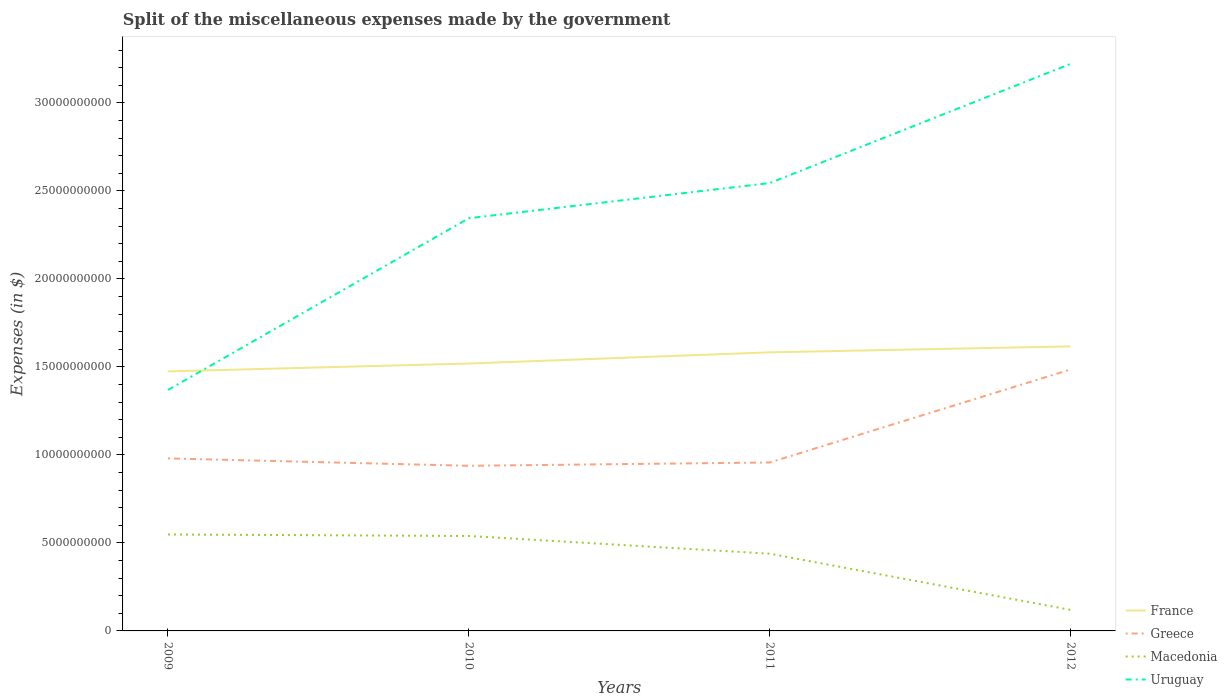How many different coloured lines are there?
Give a very brief answer. 4. Across all years, what is the maximum miscellaneous expenses made by the government in France?
Provide a short and direct response. 1.47e+1. What is the total miscellaneous expenses made by the government in Macedonia in the graph?
Make the answer very short. 4.28e+09. What is the difference between the highest and the second highest miscellaneous expenses made by the government in Uruguay?
Your answer should be compact. 1.85e+1. What is the difference between the highest and the lowest miscellaneous expenses made by the government in Greece?
Give a very brief answer. 1. How many lines are there?
Provide a succinct answer. 4. Are the values on the major ticks of Y-axis written in scientific E-notation?
Keep it short and to the point. No. Does the graph contain grids?
Your response must be concise. No. How are the legend labels stacked?
Your answer should be compact. Vertical. What is the title of the graph?
Your answer should be compact. Split of the miscellaneous expenses made by the government. What is the label or title of the Y-axis?
Provide a succinct answer. Expenses (in $). What is the Expenses (in $) in France in 2009?
Give a very brief answer. 1.47e+1. What is the Expenses (in $) in Greece in 2009?
Give a very brief answer. 9.80e+09. What is the Expenses (in $) of Macedonia in 2009?
Provide a short and direct response. 5.48e+09. What is the Expenses (in $) in Uruguay in 2009?
Offer a terse response. 1.37e+1. What is the Expenses (in $) in France in 2010?
Your answer should be very brief. 1.52e+1. What is the Expenses (in $) of Greece in 2010?
Your response must be concise. 9.38e+09. What is the Expenses (in $) of Macedonia in 2010?
Your answer should be very brief. 5.39e+09. What is the Expenses (in $) in Uruguay in 2010?
Provide a short and direct response. 2.34e+1. What is the Expenses (in $) in France in 2011?
Your response must be concise. 1.58e+1. What is the Expenses (in $) in Greece in 2011?
Provide a short and direct response. 9.57e+09. What is the Expenses (in $) of Macedonia in 2011?
Keep it short and to the point. 4.39e+09. What is the Expenses (in $) of Uruguay in 2011?
Offer a terse response. 2.54e+1. What is the Expenses (in $) in France in 2012?
Your answer should be compact. 1.62e+1. What is the Expenses (in $) in Greece in 2012?
Offer a terse response. 1.49e+1. What is the Expenses (in $) of Macedonia in 2012?
Your response must be concise. 1.20e+09. What is the Expenses (in $) in Uruguay in 2012?
Keep it short and to the point. 3.22e+1. Across all years, what is the maximum Expenses (in $) of France?
Make the answer very short. 1.62e+1. Across all years, what is the maximum Expenses (in $) in Greece?
Your answer should be very brief. 1.49e+1. Across all years, what is the maximum Expenses (in $) of Macedonia?
Give a very brief answer. 5.48e+09. Across all years, what is the maximum Expenses (in $) in Uruguay?
Offer a terse response. 3.22e+1. Across all years, what is the minimum Expenses (in $) of France?
Offer a terse response. 1.47e+1. Across all years, what is the minimum Expenses (in $) in Greece?
Offer a terse response. 9.38e+09. Across all years, what is the minimum Expenses (in $) of Macedonia?
Keep it short and to the point. 1.20e+09. Across all years, what is the minimum Expenses (in $) of Uruguay?
Your answer should be very brief. 1.37e+1. What is the total Expenses (in $) in France in the graph?
Offer a terse response. 6.19e+1. What is the total Expenses (in $) of Greece in the graph?
Your answer should be very brief. 4.36e+1. What is the total Expenses (in $) in Macedonia in the graph?
Your answer should be compact. 1.65e+1. What is the total Expenses (in $) of Uruguay in the graph?
Give a very brief answer. 9.48e+1. What is the difference between the Expenses (in $) of France in 2009 and that in 2010?
Keep it short and to the point. -4.47e+08. What is the difference between the Expenses (in $) in Greece in 2009 and that in 2010?
Provide a succinct answer. 4.20e+08. What is the difference between the Expenses (in $) of Macedonia in 2009 and that in 2010?
Provide a short and direct response. 8.70e+07. What is the difference between the Expenses (in $) in Uruguay in 2009 and that in 2010?
Keep it short and to the point. -9.76e+09. What is the difference between the Expenses (in $) in France in 2009 and that in 2011?
Your response must be concise. -1.08e+09. What is the difference between the Expenses (in $) in Greece in 2009 and that in 2011?
Give a very brief answer. 2.32e+08. What is the difference between the Expenses (in $) in Macedonia in 2009 and that in 2011?
Offer a very short reply. 1.09e+09. What is the difference between the Expenses (in $) in Uruguay in 2009 and that in 2011?
Keep it short and to the point. -1.18e+1. What is the difference between the Expenses (in $) in France in 2009 and that in 2012?
Give a very brief answer. -1.42e+09. What is the difference between the Expenses (in $) in Greece in 2009 and that in 2012?
Your answer should be very brief. -5.05e+09. What is the difference between the Expenses (in $) of Macedonia in 2009 and that in 2012?
Offer a very short reply. 4.28e+09. What is the difference between the Expenses (in $) of Uruguay in 2009 and that in 2012?
Ensure brevity in your answer.  -1.85e+1. What is the difference between the Expenses (in $) of France in 2010 and that in 2011?
Give a very brief answer. -6.36e+08. What is the difference between the Expenses (in $) in Greece in 2010 and that in 2011?
Your answer should be compact. -1.88e+08. What is the difference between the Expenses (in $) of Macedonia in 2010 and that in 2011?
Your answer should be compact. 1.01e+09. What is the difference between the Expenses (in $) in Uruguay in 2010 and that in 2011?
Ensure brevity in your answer.  -2.00e+09. What is the difference between the Expenses (in $) of France in 2010 and that in 2012?
Keep it short and to the point. -9.75e+08. What is the difference between the Expenses (in $) of Greece in 2010 and that in 2012?
Your response must be concise. -5.47e+09. What is the difference between the Expenses (in $) of Macedonia in 2010 and that in 2012?
Offer a terse response. 4.20e+09. What is the difference between the Expenses (in $) of Uruguay in 2010 and that in 2012?
Your answer should be very brief. -8.77e+09. What is the difference between the Expenses (in $) of France in 2011 and that in 2012?
Offer a terse response. -3.39e+08. What is the difference between the Expenses (in $) of Greece in 2011 and that in 2012?
Ensure brevity in your answer.  -5.28e+09. What is the difference between the Expenses (in $) in Macedonia in 2011 and that in 2012?
Offer a very short reply. 3.19e+09. What is the difference between the Expenses (in $) in Uruguay in 2011 and that in 2012?
Make the answer very short. -6.77e+09. What is the difference between the Expenses (in $) in France in 2009 and the Expenses (in $) in Greece in 2010?
Provide a short and direct response. 5.36e+09. What is the difference between the Expenses (in $) of France in 2009 and the Expenses (in $) of Macedonia in 2010?
Give a very brief answer. 9.35e+09. What is the difference between the Expenses (in $) in France in 2009 and the Expenses (in $) in Uruguay in 2010?
Provide a short and direct response. -8.70e+09. What is the difference between the Expenses (in $) of Greece in 2009 and the Expenses (in $) of Macedonia in 2010?
Your answer should be compact. 4.41e+09. What is the difference between the Expenses (in $) in Greece in 2009 and the Expenses (in $) in Uruguay in 2010?
Keep it short and to the point. -1.36e+1. What is the difference between the Expenses (in $) in Macedonia in 2009 and the Expenses (in $) in Uruguay in 2010?
Your response must be concise. -1.80e+1. What is the difference between the Expenses (in $) of France in 2009 and the Expenses (in $) of Greece in 2011?
Keep it short and to the point. 5.17e+09. What is the difference between the Expenses (in $) of France in 2009 and the Expenses (in $) of Macedonia in 2011?
Provide a succinct answer. 1.04e+1. What is the difference between the Expenses (in $) in France in 2009 and the Expenses (in $) in Uruguay in 2011?
Ensure brevity in your answer.  -1.07e+1. What is the difference between the Expenses (in $) of Greece in 2009 and the Expenses (in $) of Macedonia in 2011?
Ensure brevity in your answer.  5.41e+09. What is the difference between the Expenses (in $) of Greece in 2009 and the Expenses (in $) of Uruguay in 2011?
Keep it short and to the point. -1.56e+1. What is the difference between the Expenses (in $) in Macedonia in 2009 and the Expenses (in $) in Uruguay in 2011?
Your answer should be compact. -2.00e+1. What is the difference between the Expenses (in $) of France in 2009 and the Expenses (in $) of Greece in 2012?
Provide a succinct answer. -1.10e+08. What is the difference between the Expenses (in $) of France in 2009 and the Expenses (in $) of Macedonia in 2012?
Give a very brief answer. 1.35e+1. What is the difference between the Expenses (in $) in France in 2009 and the Expenses (in $) in Uruguay in 2012?
Your response must be concise. -1.75e+1. What is the difference between the Expenses (in $) of Greece in 2009 and the Expenses (in $) of Macedonia in 2012?
Your answer should be compact. 8.60e+09. What is the difference between the Expenses (in $) of Greece in 2009 and the Expenses (in $) of Uruguay in 2012?
Ensure brevity in your answer.  -2.24e+1. What is the difference between the Expenses (in $) in Macedonia in 2009 and the Expenses (in $) in Uruguay in 2012?
Provide a succinct answer. -2.67e+1. What is the difference between the Expenses (in $) in France in 2010 and the Expenses (in $) in Greece in 2011?
Your answer should be compact. 5.62e+09. What is the difference between the Expenses (in $) in France in 2010 and the Expenses (in $) in Macedonia in 2011?
Your answer should be compact. 1.08e+1. What is the difference between the Expenses (in $) in France in 2010 and the Expenses (in $) in Uruguay in 2011?
Ensure brevity in your answer.  -1.03e+1. What is the difference between the Expenses (in $) in Greece in 2010 and the Expenses (in $) in Macedonia in 2011?
Keep it short and to the point. 4.99e+09. What is the difference between the Expenses (in $) of Greece in 2010 and the Expenses (in $) of Uruguay in 2011?
Give a very brief answer. -1.61e+1. What is the difference between the Expenses (in $) in Macedonia in 2010 and the Expenses (in $) in Uruguay in 2011?
Provide a succinct answer. -2.00e+1. What is the difference between the Expenses (in $) in France in 2010 and the Expenses (in $) in Greece in 2012?
Provide a succinct answer. 3.37e+08. What is the difference between the Expenses (in $) of France in 2010 and the Expenses (in $) of Macedonia in 2012?
Your answer should be compact. 1.40e+1. What is the difference between the Expenses (in $) in France in 2010 and the Expenses (in $) in Uruguay in 2012?
Provide a succinct answer. -1.70e+1. What is the difference between the Expenses (in $) in Greece in 2010 and the Expenses (in $) in Macedonia in 2012?
Your answer should be very brief. 8.18e+09. What is the difference between the Expenses (in $) in Greece in 2010 and the Expenses (in $) in Uruguay in 2012?
Offer a very short reply. -2.28e+1. What is the difference between the Expenses (in $) in Macedonia in 2010 and the Expenses (in $) in Uruguay in 2012?
Make the answer very short. -2.68e+1. What is the difference between the Expenses (in $) of France in 2011 and the Expenses (in $) of Greece in 2012?
Make the answer very short. 9.73e+08. What is the difference between the Expenses (in $) of France in 2011 and the Expenses (in $) of Macedonia in 2012?
Your answer should be compact. 1.46e+1. What is the difference between the Expenses (in $) in France in 2011 and the Expenses (in $) in Uruguay in 2012?
Offer a terse response. -1.64e+1. What is the difference between the Expenses (in $) in Greece in 2011 and the Expenses (in $) in Macedonia in 2012?
Offer a very short reply. 8.37e+09. What is the difference between the Expenses (in $) of Greece in 2011 and the Expenses (in $) of Uruguay in 2012?
Give a very brief answer. -2.26e+1. What is the difference between the Expenses (in $) in Macedonia in 2011 and the Expenses (in $) in Uruguay in 2012?
Provide a succinct answer. -2.78e+1. What is the average Expenses (in $) in France per year?
Make the answer very short. 1.55e+1. What is the average Expenses (in $) in Greece per year?
Keep it short and to the point. 1.09e+1. What is the average Expenses (in $) in Macedonia per year?
Your answer should be very brief. 4.11e+09. What is the average Expenses (in $) of Uruguay per year?
Offer a terse response. 2.37e+1. In the year 2009, what is the difference between the Expenses (in $) in France and Expenses (in $) in Greece?
Keep it short and to the point. 4.94e+09. In the year 2009, what is the difference between the Expenses (in $) in France and Expenses (in $) in Macedonia?
Provide a succinct answer. 9.26e+09. In the year 2009, what is the difference between the Expenses (in $) of France and Expenses (in $) of Uruguay?
Keep it short and to the point. 1.05e+09. In the year 2009, what is the difference between the Expenses (in $) of Greece and Expenses (in $) of Macedonia?
Keep it short and to the point. 4.32e+09. In the year 2009, what is the difference between the Expenses (in $) of Greece and Expenses (in $) of Uruguay?
Offer a very short reply. -3.89e+09. In the year 2009, what is the difference between the Expenses (in $) in Macedonia and Expenses (in $) in Uruguay?
Provide a succinct answer. -8.21e+09. In the year 2010, what is the difference between the Expenses (in $) of France and Expenses (in $) of Greece?
Offer a very short reply. 5.81e+09. In the year 2010, what is the difference between the Expenses (in $) of France and Expenses (in $) of Macedonia?
Your answer should be compact. 9.80e+09. In the year 2010, what is the difference between the Expenses (in $) in France and Expenses (in $) in Uruguay?
Provide a succinct answer. -8.26e+09. In the year 2010, what is the difference between the Expenses (in $) in Greece and Expenses (in $) in Macedonia?
Your response must be concise. 3.99e+09. In the year 2010, what is the difference between the Expenses (in $) of Greece and Expenses (in $) of Uruguay?
Give a very brief answer. -1.41e+1. In the year 2010, what is the difference between the Expenses (in $) in Macedonia and Expenses (in $) in Uruguay?
Your answer should be compact. -1.81e+1. In the year 2011, what is the difference between the Expenses (in $) in France and Expenses (in $) in Greece?
Your answer should be compact. 6.26e+09. In the year 2011, what is the difference between the Expenses (in $) of France and Expenses (in $) of Macedonia?
Offer a very short reply. 1.14e+1. In the year 2011, what is the difference between the Expenses (in $) in France and Expenses (in $) in Uruguay?
Offer a very short reply. -9.62e+09. In the year 2011, what is the difference between the Expenses (in $) in Greece and Expenses (in $) in Macedonia?
Provide a succinct answer. 5.18e+09. In the year 2011, what is the difference between the Expenses (in $) of Greece and Expenses (in $) of Uruguay?
Your answer should be very brief. -1.59e+1. In the year 2011, what is the difference between the Expenses (in $) of Macedonia and Expenses (in $) of Uruguay?
Offer a very short reply. -2.11e+1. In the year 2012, what is the difference between the Expenses (in $) in France and Expenses (in $) in Greece?
Provide a short and direct response. 1.31e+09. In the year 2012, what is the difference between the Expenses (in $) of France and Expenses (in $) of Macedonia?
Offer a very short reply. 1.50e+1. In the year 2012, what is the difference between the Expenses (in $) in France and Expenses (in $) in Uruguay?
Offer a terse response. -1.60e+1. In the year 2012, what is the difference between the Expenses (in $) in Greece and Expenses (in $) in Macedonia?
Keep it short and to the point. 1.37e+1. In the year 2012, what is the difference between the Expenses (in $) of Greece and Expenses (in $) of Uruguay?
Your answer should be very brief. -1.74e+1. In the year 2012, what is the difference between the Expenses (in $) in Macedonia and Expenses (in $) in Uruguay?
Your response must be concise. -3.10e+1. What is the ratio of the Expenses (in $) of France in 2009 to that in 2010?
Ensure brevity in your answer.  0.97. What is the ratio of the Expenses (in $) in Greece in 2009 to that in 2010?
Your response must be concise. 1.04. What is the ratio of the Expenses (in $) of Macedonia in 2009 to that in 2010?
Ensure brevity in your answer.  1.02. What is the ratio of the Expenses (in $) in Uruguay in 2009 to that in 2010?
Offer a very short reply. 0.58. What is the ratio of the Expenses (in $) of France in 2009 to that in 2011?
Ensure brevity in your answer.  0.93. What is the ratio of the Expenses (in $) of Greece in 2009 to that in 2011?
Make the answer very short. 1.02. What is the ratio of the Expenses (in $) of Macedonia in 2009 to that in 2011?
Your response must be concise. 1.25. What is the ratio of the Expenses (in $) of Uruguay in 2009 to that in 2011?
Provide a short and direct response. 0.54. What is the ratio of the Expenses (in $) in France in 2009 to that in 2012?
Keep it short and to the point. 0.91. What is the ratio of the Expenses (in $) of Greece in 2009 to that in 2012?
Your response must be concise. 0.66. What is the ratio of the Expenses (in $) in Macedonia in 2009 to that in 2012?
Provide a short and direct response. 4.58. What is the ratio of the Expenses (in $) in Uruguay in 2009 to that in 2012?
Ensure brevity in your answer.  0.42. What is the ratio of the Expenses (in $) of France in 2010 to that in 2011?
Provide a succinct answer. 0.96. What is the ratio of the Expenses (in $) of Greece in 2010 to that in 2011?
Provide a succinct answer. 0.98. What is the ratio of the Expenses (in $) in Macedonia in 2010 to that in 2011?
Ensure brevity in your answer.  1.23. What is the ratio of the Expenses (in $) in Uruguay in 2010 to that in 2011?
Offer a terse response. 0.92. What is the ratio of the Expenses (in $) in France in 2010 to that in 2012?
Ensure brevity in your answer.  0.94. What is the ratio of the Expenses (in $) of Greece in 2010 to that in 2012?
Provide a short and direct response. 0.63. What is the ratio of the Expenses (in $) of Macedonia in 2010 to that in 2012?
Make the answer very short. 4.51. What is the ratio of the Expenses (in $) of Uruguay in 2010 to that in 2012?
Give a very brief answer. 0.73. What is the ratio of the Expenses (in $) in France in 2011 to that in 2012?
Ensure brevity in your answer.  0.98. What is the ratio of the Expenses (in $) in Greece in 2011 to that in 2012?
Provide a short and direct response. 0.64. What is the ratio of the Expenses (in $) of Macedonia in 2011 to that in 2012?
Your answer should be compact. 3.67. What is the ratio of the Expenses (in $) of Uruguay in 2011 to that in 2012?
Provide a succinct answer. 0.79. What is the difference between the highest and the second highest Expenses (in $) in France?
Keep it short and to the point. 3.39e+08. What is the difference between the highest and the second highest Expenses (in $) in Greece?
Ensure brevity in your answer.  5.05e+09. What is the difference between the highest and the second highest Expenses (in $) in Macedonia?
Offer a terse response. 8.70e+07. What is the difference between the highest and the second highest Expenses (in $) of Uruguay?
Give a very brief answer. 6.77e+09. What is the difference between the highest and the lowest Expenses (in $) of France?
Ensure brevity in your answer.  1.42e+09. What is the difference between the highest and the lowest Expenses (in $) in Greece?
Offer a terse response. 5.47e+09. What is the difference between the highest and the lowest Expenses (in $) in Macedonia?
Your response must be concise. 4.28e+09. What is the difference between the highest and the lowest Expenses (in $) of Uruguay?
Offer a terse response. 1.85e+1. 